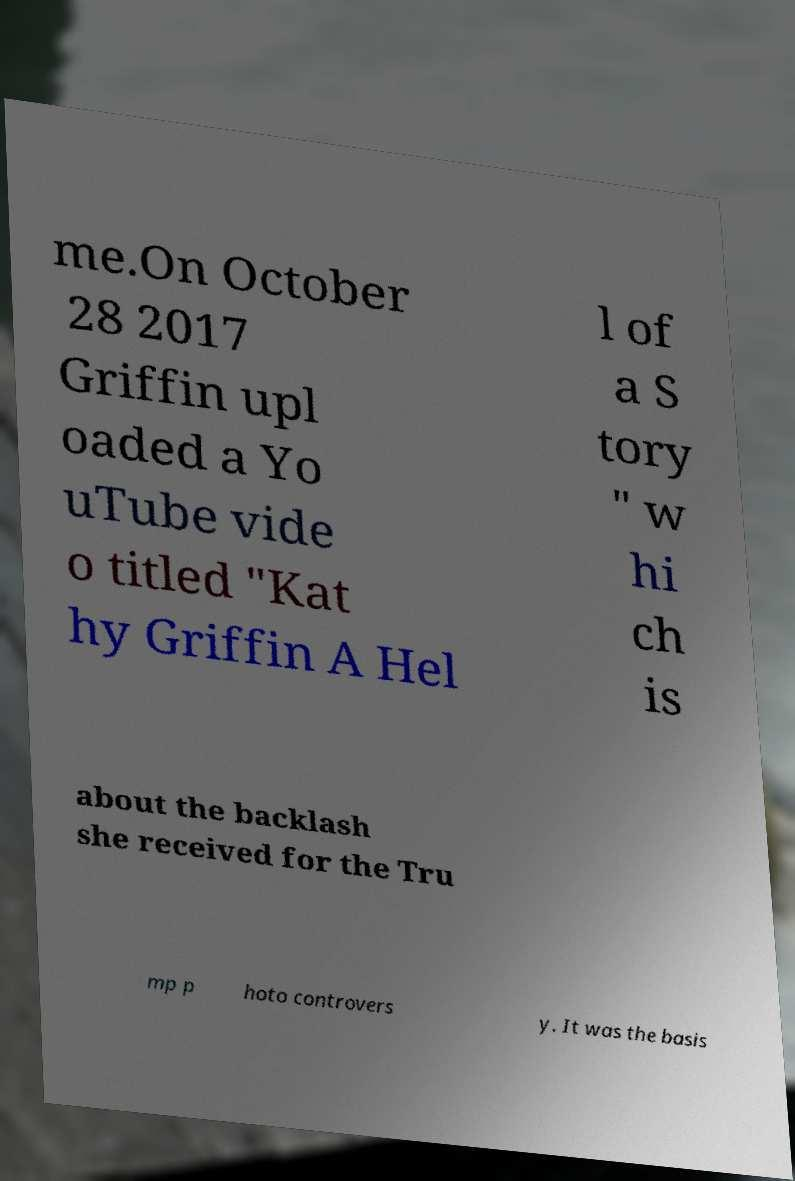Could you extract and type out the text from this image? me.On October 28 2017 Griffin upl oaded a Yo uTube vide o titled "Kat hy Griffin A Hel l of a S tory " w hi ch is about the backlash she received for the Tru mp p hoto controvers y. It was the basis 